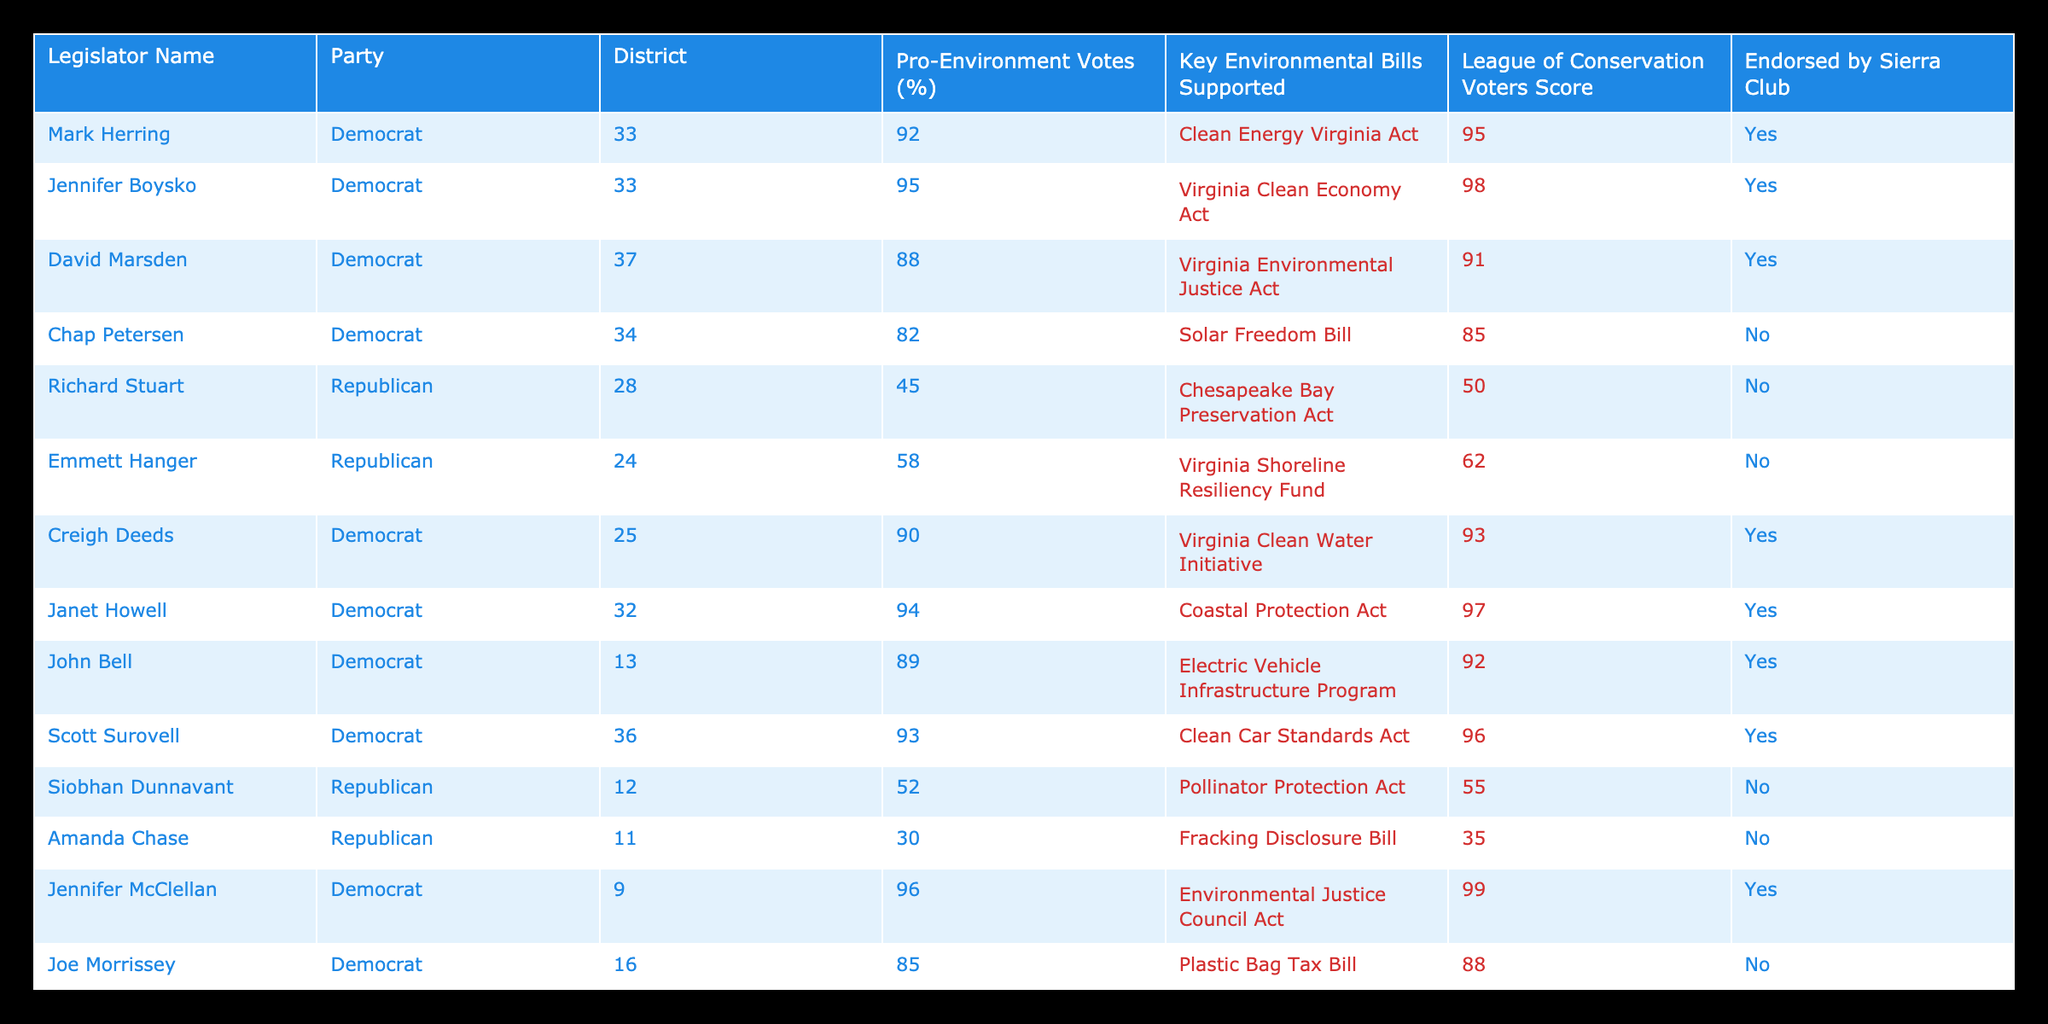What is the League of Conservation Voters Score for Jennifer Boysko? According to the table, Jennifer Boysko has a League of Conservation Voters Score of 98.
Answer: 98 How many Republicans supported the Virginia Environmental Justice Act? The Virginia Environmental Justice Act was supported by David Marsden, a Democrat. Therefore, no Republicans supported this bill.
Answer: 0 What is the average percentage of Pro-Environment Votes among all Democratic legislators? The Pro-Environment Votes for the Democratic legislators are 92, 95, 88, 82, 90, 94, 89, 93, 96, 87. Summing these gives 912. There are 10 Democrats, so the average is 912/10 = 91.2.
Answer: 91.2 Which legislator has the lowest Pro-Environment Votes and what is the percentage? The legislator with the lowest Pro-Environment Votes is Amanda Chase, who has a percentage of 30.
Answer: 30 Is Mark Herring endorsed by the Sierra Club? Yes, Mark Herring is endorsed by the Sierra Club, as indicated in the table.
Answer: Yes How many legislators have a Pro-Environment Votes percentage of 90 or more? The legislators with a Pro-Environment Votes percentage of 90 or more are Jennifer Boysko, Creigh Deeds, Janet Howell, John Bell, Scott Surovell, and Jennifer McClellan. Counting these gives a total of 6 legislators.
Answer: 6 What percentage of Republican legislators supported the Coastal Protection Act? The Coastal Protection Act was supported by Janet Howell, a Democrat. Therefore, no Republican legislators supported this bill, resulting in a percentage of 0%.
Answer: 0% Which Democratic legislator has the highest Pro-Environment Votes percentage and what is it? The legislator with the highest Pro-Environment Votes percentage is Jennifer McClellan, with a percentage of 96.
Answer: 96 How does the Pro-Environment Votes percentage of Richard Stuart compare to the average for all legislators? Richard Stuart has a Pro-Environment Votes percentage of 45. To find the average for all legislators, sum them (total is 82) and divide by the total number (15), which is approximately 69. Therefore, Richard Stuart's percentage is below average.
Answer: Below average 